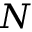<formula> <loc_0><loc_0><loc_500><loc_500>N</formula> 